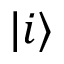Convert formula to latex. <formula><loc_0><loc_0><loc_500><loc_500>| i \rangle</formula> 